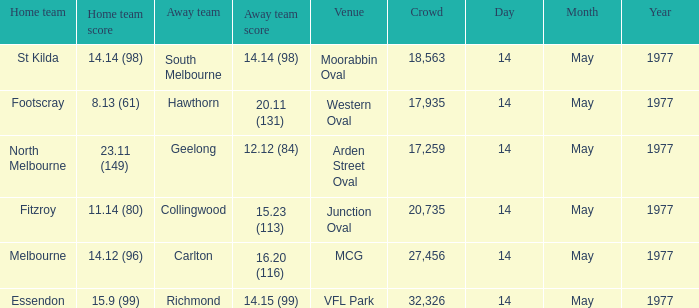Specify the visiting team against essendon. Richmond. 